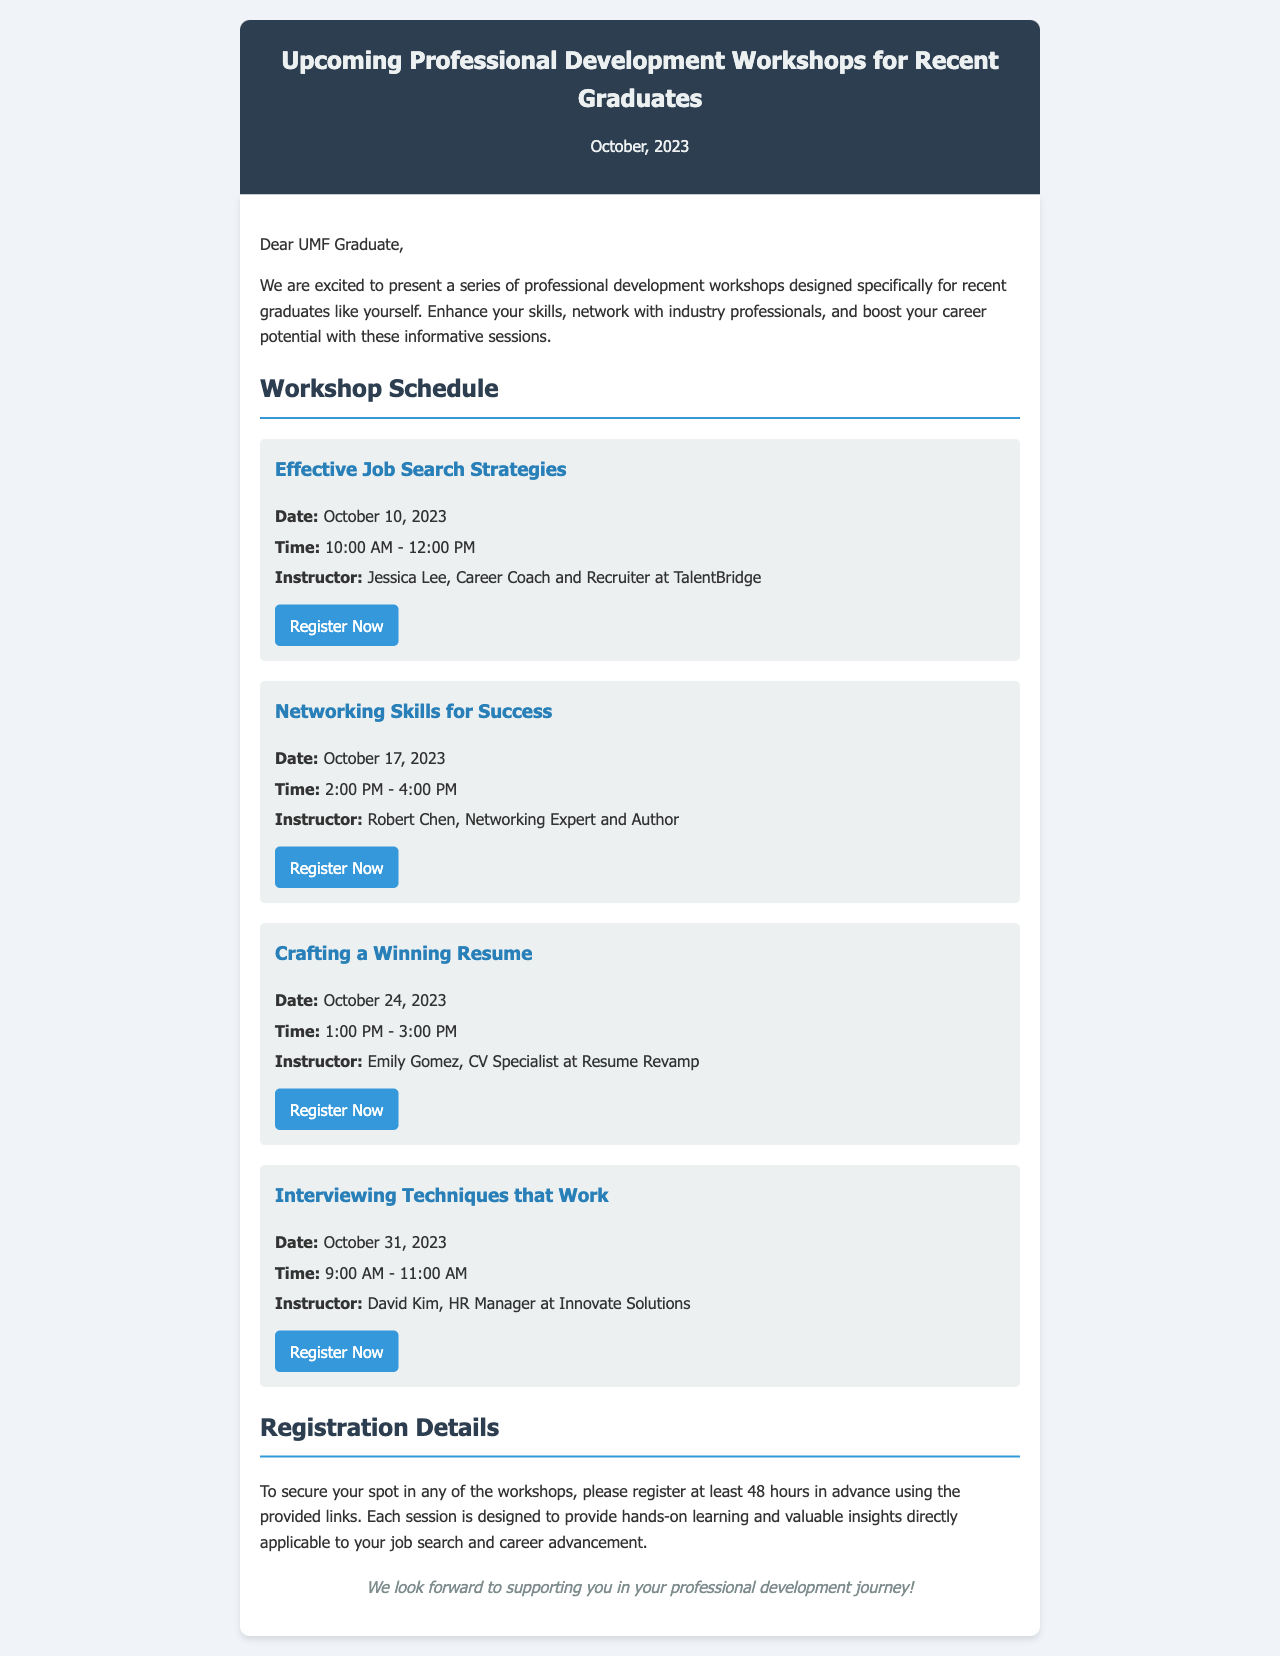What is the date of the first workshop? The first workshop is titled "Effective Job Search Strategies," and it is scheduled for October 10, 2023.
Answer: October 10, 2023 Who is the instructor for the "Crafting a Winning Resume" workshop? The workshop "Crafting a Winning Resume" is instructed by Emily Gomez, a CV Specialist at Resume Revamp.
Answer: Emily Gomez What time does the "Networking Skills for Success" workshop start? The "Networking Skills for Success" workshop starts at 2:00 PM.
Answer: 2:00 PM How many workshops are listed in the document? The document lists a total of four workshops for recent graduates.
Answer: Four What is the registration deadline for the workshops? The document states that participants should register at least 48 hours in advance for the workshops.
Answer: 48 hours What is the main purpose of the workshops? The workshops are designed to enhance skills, network with industry professionals, and boost career potential.
Answer: Enhance skills Who is the target audience for these workshops? The workshops are specifically designed for recent graduates like the reader.
Answer: Recent graduates 